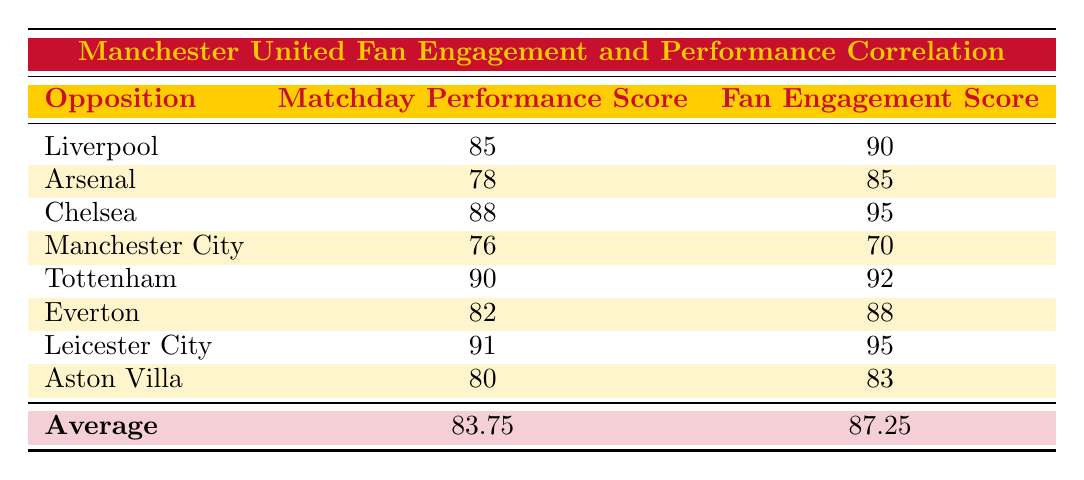What is the Matchday Performance Score against Chelsea? From the table, the row for Chelsea shows a Matchday Performance Score of 88.
Answer: 88 What was the Fan Engagement Score in the match against Leicester City? According to the table, Leicester City has a Fan Engagement Score of 95.
Answer: 95 Which match had the lowest Matchday Performance Score? Scanning across the Matchday Performance Scores, Manchester City has the lowest score at 76.
Answer: 76 What is the average Fan Engagement Score for the matches listed? By adding the Fan Engagement Scores (90 + 85 + 95 + 70 + 92 + 88 + 95 + 83 =  798) and dividing by the number of matches (8), we get 798/8 = 99.75.
Answer: 87.25 Is there a match where the Fan Engagement Score is higher than the Matchday Performance Score? Yes, in the match against Manchester City, the Fan Engagement Score is 70, which is lower than the Matchday Performance Score of 76.
Answer: No What is the difference between the highest and lowest Matchday Performance Scores? The highest score is 91 (against Leicester City) and the lowest is 76 (against Manchester City); the difference is 91 - 76 = 15.
Answer: 15 Did every match against the rivals provide a Fan Engagement Score above 80? Checking the Fan Engagement Scores, the match against Manchester City only had a score of 70, which is below 80.
Answer: No In which match did Manchester United perform better regarding Matchday Performance relative to Fan Engagement? The best match in this aspect was against Tottenham, where the Matchday Performance Score was 90 and the Fan Engagement Score was 92, showing solid engagement.
Answer: Tottenham 